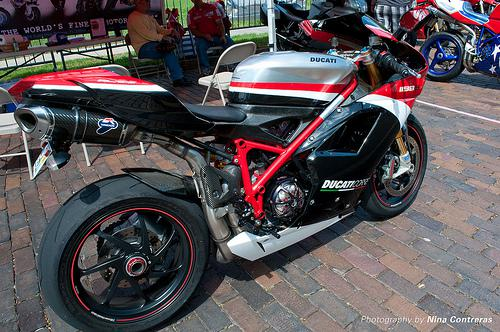Question: who is this a picture of?
Choices:
A. Jesus.
B. Mary.
C. No one.
D. Joseph.
Answer with the letter. Answer: C Question: what is the brand of this motorcycle?
Choices:
A. Honda.
B. Ducati.
C. Kawasaki.
D. Bmw.
Answer with the letter. Answer: B Question: what color is the top of the gas tank?
Choices:
A. Black.
B. Gray.
C. White.
D. Silver.
Answer with the letter. Answer: D Question: how many colors on this motorcycle?
Choices:
A. Two.
B. One.
C. Three.
D. Four.
Answer with the letter. Answer: D 